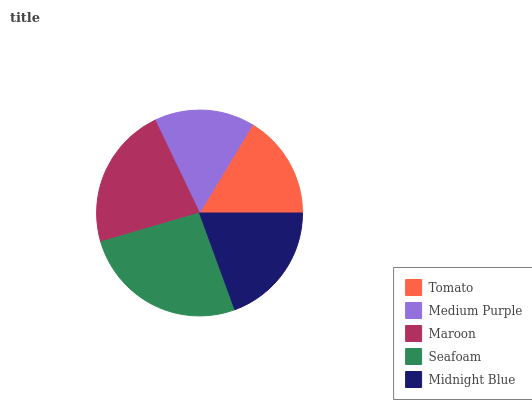Is Medium Purple the minimum?
Answer yes or no. Yes. Is Seafoam the maximum?
Answer yes or no. Yes. Is Maroon the minimum?
Answer yes or no. No. Is Maroon the maximum?
Answer yes or no. No. Is Maroon greater than Medium Purple?
Answer yes or no. Yes. Is Medium Purple less than Maroon?
Answer yes or no. Yes. Is Medium Purple greater than Maroon?
Answer yes or no. No. Is Maroon less than Medium Purple?
Answer yes or no. No. Is Midnight Blue the high median?
Answer yes or no. Yes. Is Midnight Blue the low median?
Answer yes or no. Yes. Is Tomato the high median?
Answer yes or no. No. Is Seafoam the low median?
Answer yes or no. No. 